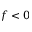Convert formula to latex. <formula><loc_0><loc_0><loc_500><loc_500>f < 0</formula> 